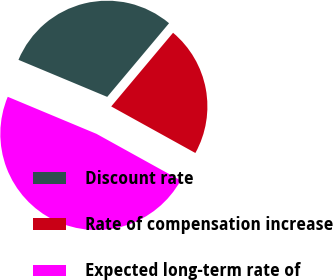<chart> <loc_0><loc_0><loc_500><loc_500><pie_chart><fcel>Discount rate<fcel>Rate of compensation increase<fcel>Expected long-term rate of<nl><fcel>29.82%<fcel>21.93%<fcel>48.25%<nl></chart> 